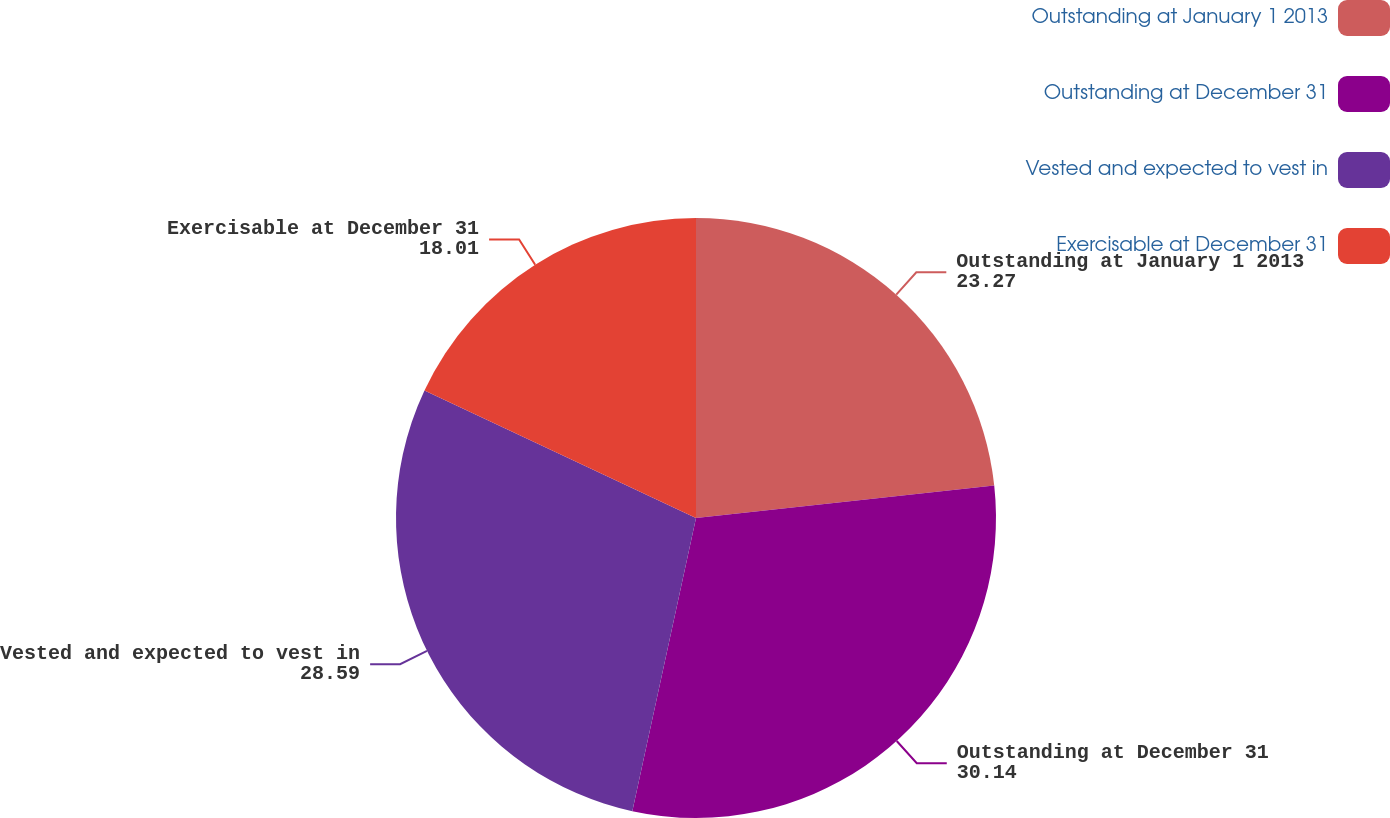<chart> <loc_0><loc_0><loc_500><loc_500><pie_chart><fcel>Outstanding at January 1 2013<fcel>Outstanding at December 31<fcel>Vested and expected to vest in<fcel>Exercisable at December 31<nl><fcel>23.27%<fcel>30.14%<fcel>28.59%<fcel>18.01%<nl></chart> 